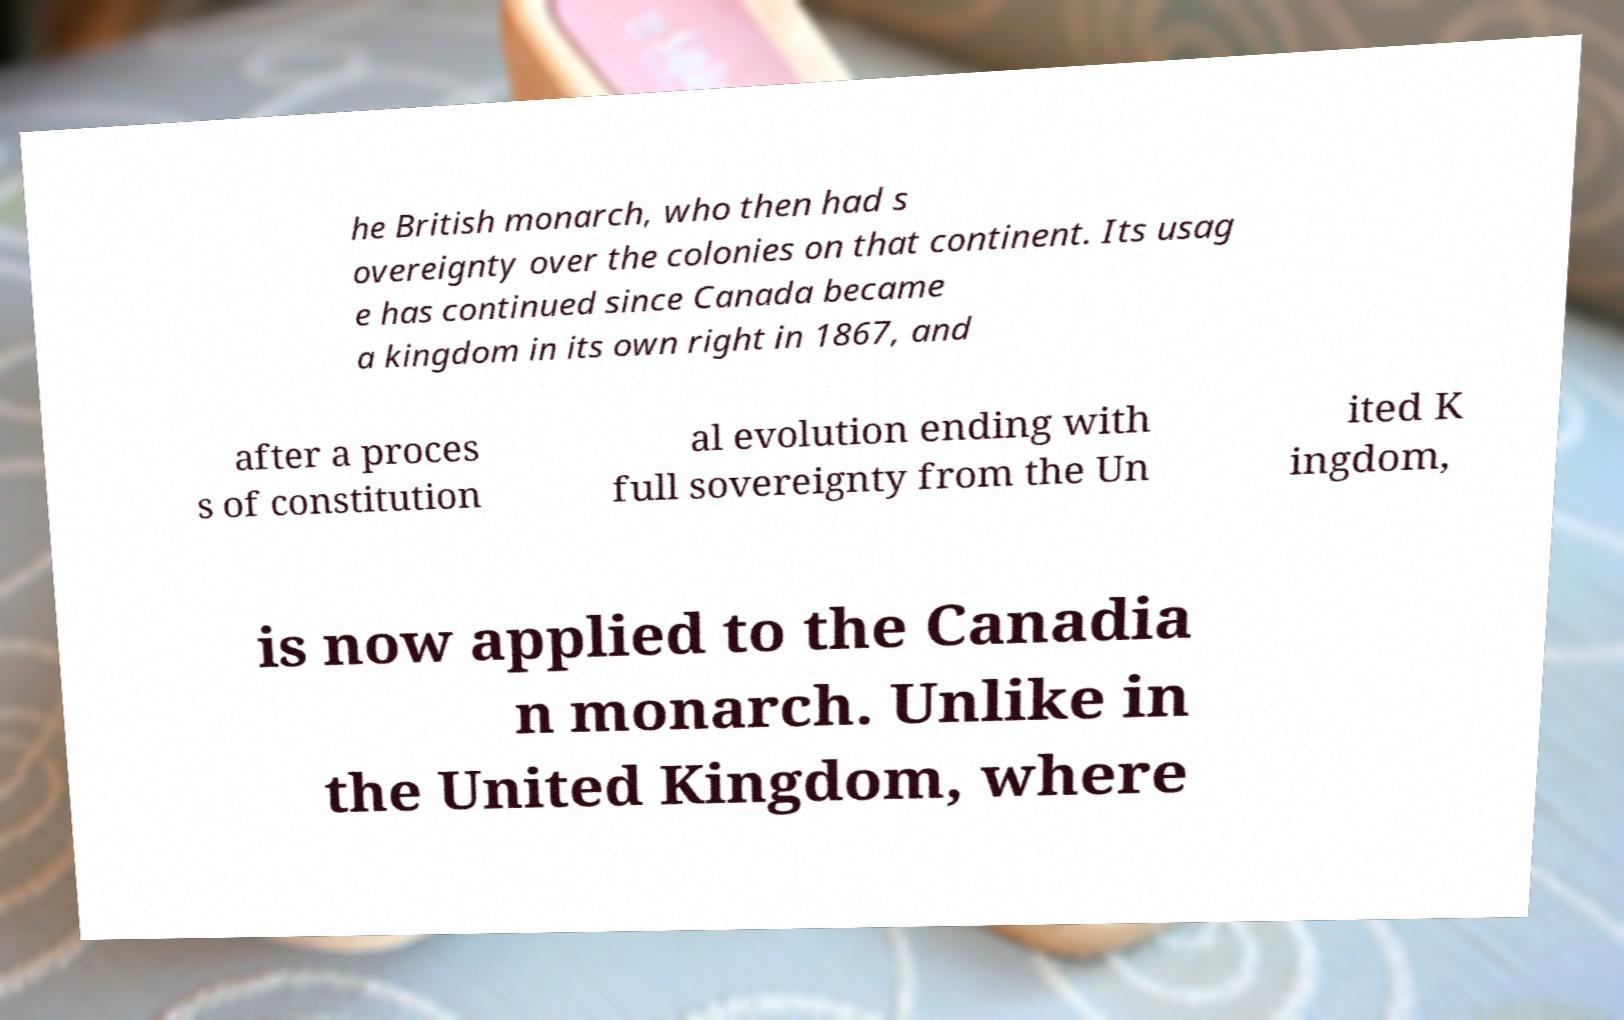Could you extract and type out the text from this image? he British monarch, who then had s overeignty over the colonies on that continent. Its usag e has continued since Canada became a kingdom in its own right in 1867, and after a proces s of constitution al evolution ending with full sovereignty from the Un ited K ingdom, is now applied to the Canadia n monarch. Unlike in the United Kingdom, where 